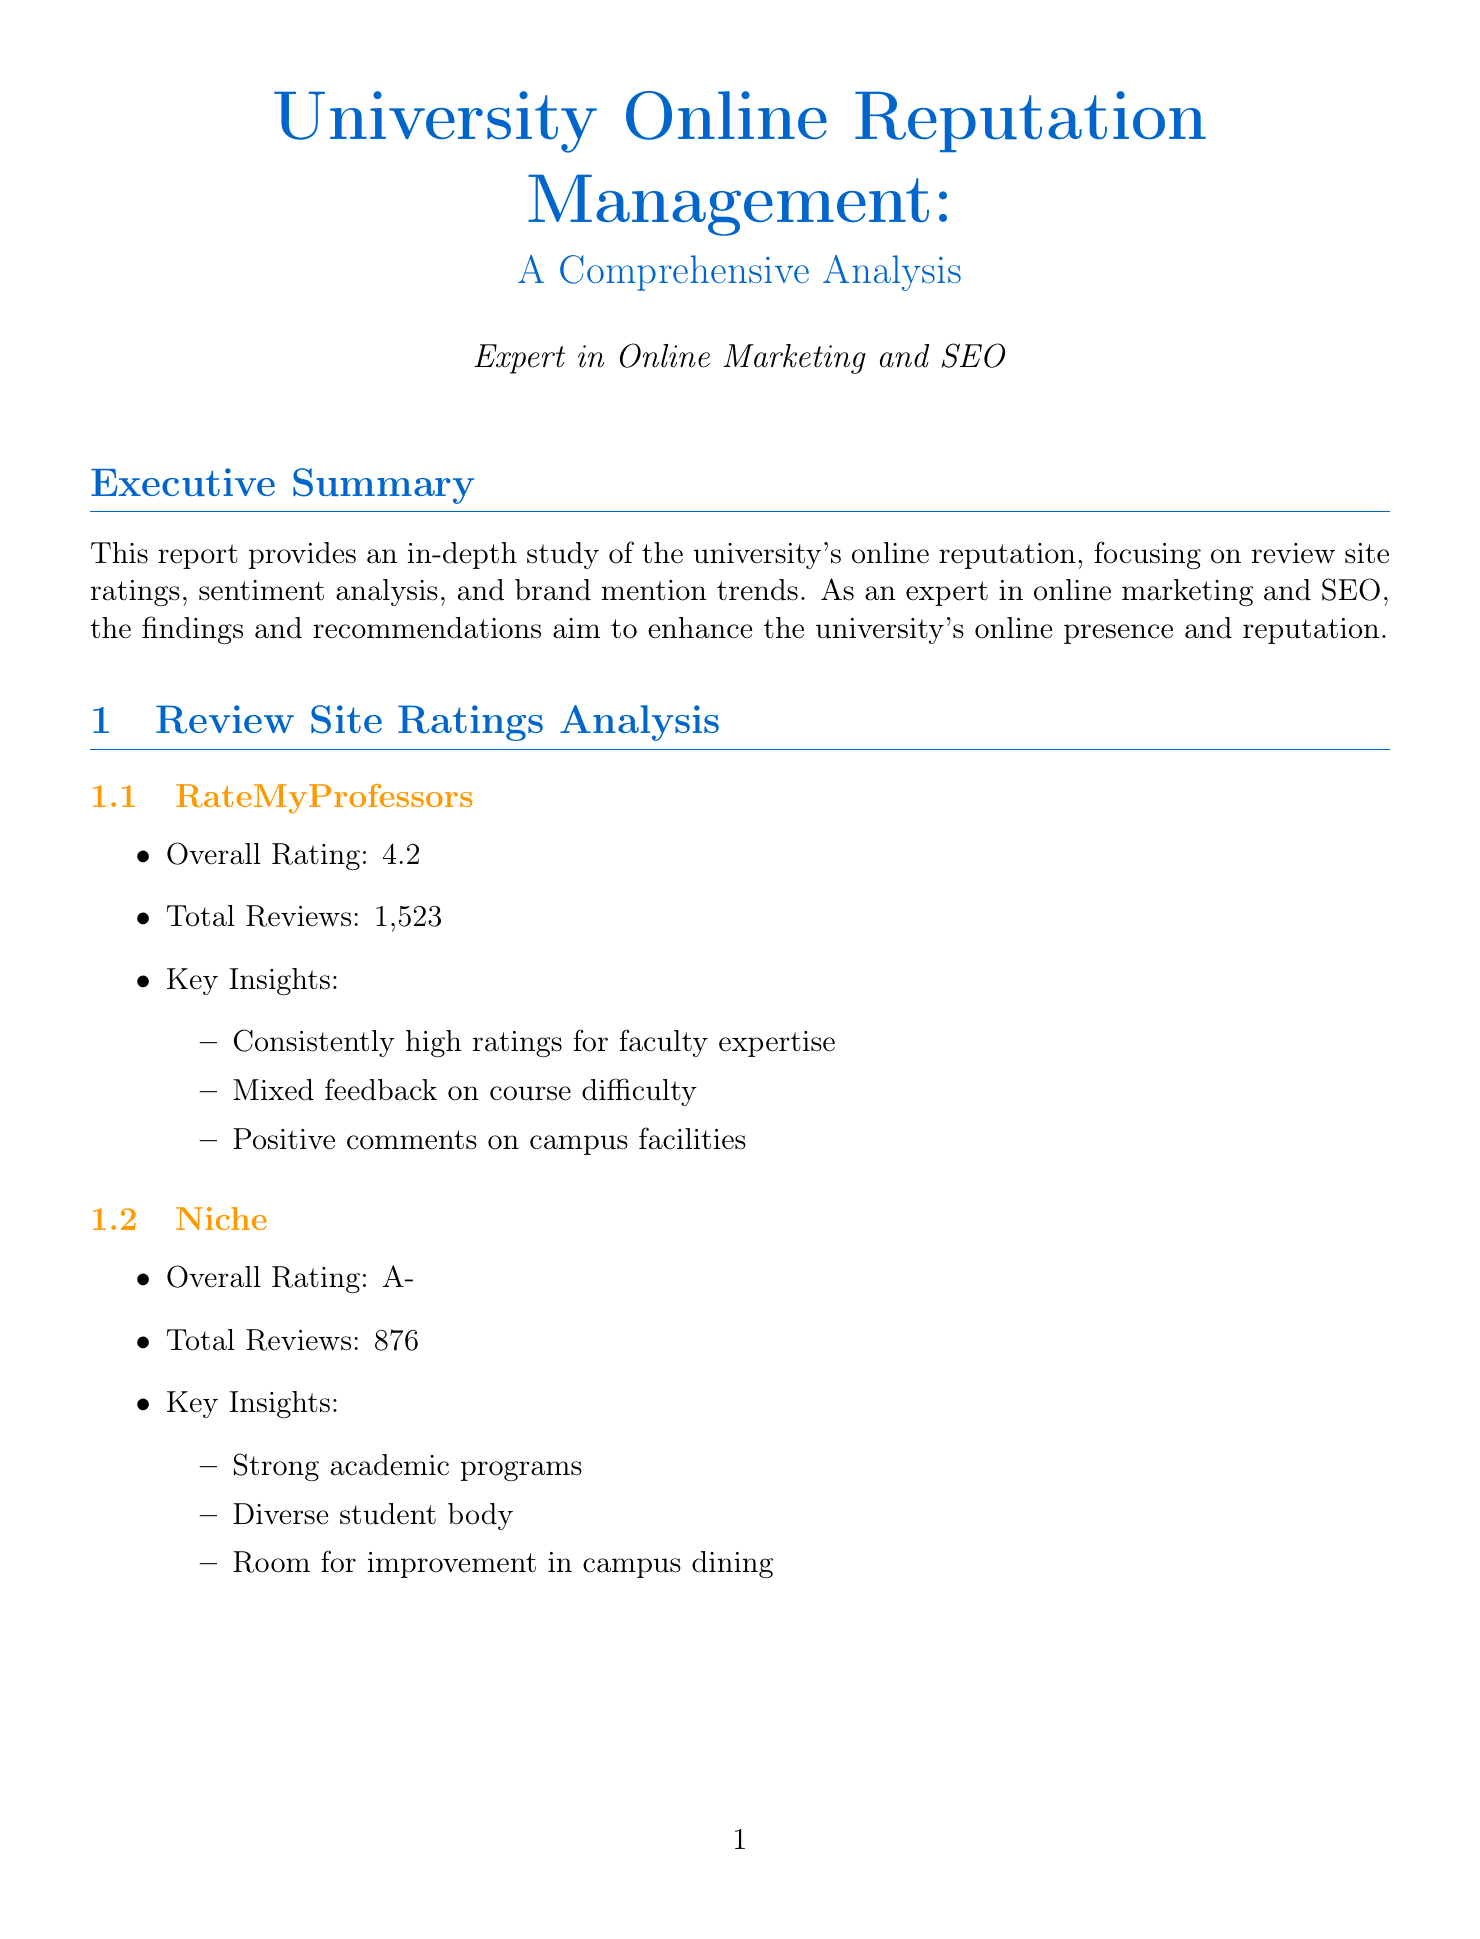What is the overall rating on RateMyProfessors? The overall rating on RateMyProfessors is 4.2 according to the review site ratings analysis.
Answer: 4.2 What percentage of sentiment in news articles is positive? The sentiment analysis indicates that 72% of sentiment in news articles is positive.
Answer: 72% How many total reviews are there on Google Reviews? According to the review site ratings analysis, there are a total of 2,154 reviews on Google Reviews.
Answer: 2,154 What is the average mentions per day on Instagram? In the brand mention trends section, the average mentions per day on Instagram is noted as 500.
Answer: 500 What is a key weakness of Tech Institute compared to our university? A key weakness of Tech Institute compared to our university is that it has limited liberal arts offerings.
Answer: Limited liberal arts offerings Which platform shows high influencer engagement? The brand mention trends analysis specifies that Twitter shows high influencer engagement.
Answer: Twitter What recommendation involves alumni success stories? The recommendations section advises leveraging alumni success stories to boost brand mentions and positive sentiment.
Answer: Boost brand mentions and positive sentiment What is the organic search traffic for the university? The SEO performance section states that the organic search traffic is currently at 250,000 monthly visits.
Answer: 250,000 monthly visits 